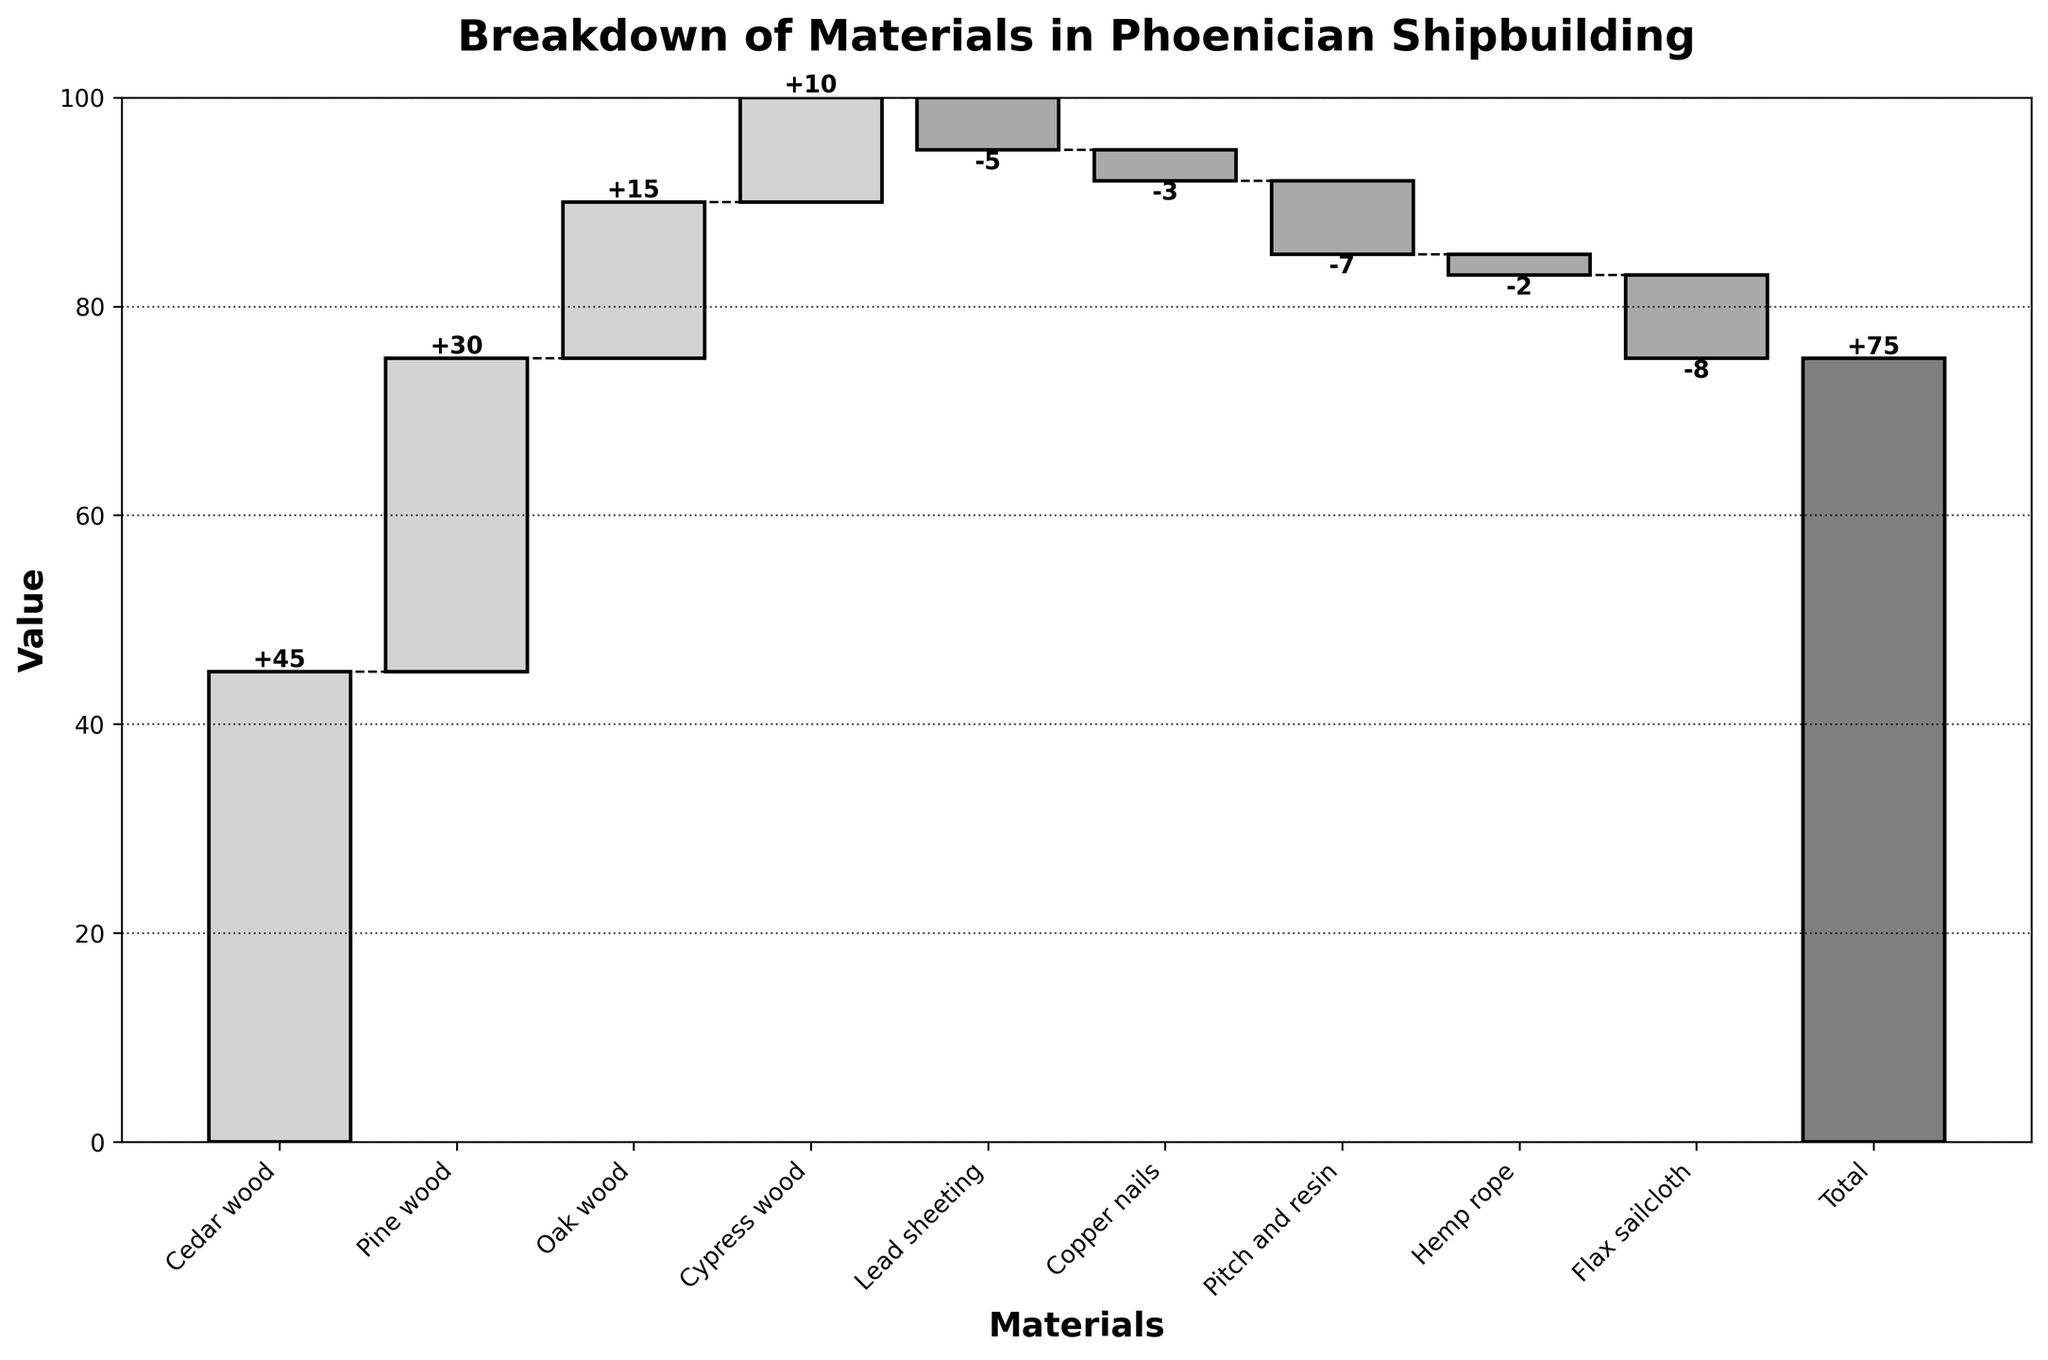What's the title of the chart? The title is usually at the top of the chart and indicates what the chart represents. In this case, the title should be easily readable.
Answer: Breakdown of Materials in Phoenician Shipbuilding How many materials are positively contributing to the total value? Materials that positively contribute will have positive values. By counting these from the bars that go upwards, we identify the count.
Answer: 4 Which material has the highest contribution? From the chart, we see which bar is the highest in terms of positive value. The highest bar indicates the largest contribution.
Answer: Cedar wood Which material has the smallest negative contribution? We look for the smallest negative value from the bars that go downward and identify the respective material.
Answer: Hemp rope How does the contribution of lead sheeting compare to copper nails? We observe the heights of the bars for lead sheeting and copper nails, both of which go downward, and compare their magnitudes.
Answer: Lead sheeting has a larger negative contribution than copper nails What's the net positive value before considering the negative values? We sum up the values of the positively contributing materials: Cedar wood (45), Pine wood (30), Oak wood (15), and Cypress wood (10).
Answer: 45 + 30 + 15 + 10 = 100 What is the net effect of materials that negatively contribute? We sum up the absolute values of the negatively contributing materials: Lead sheeting (5), Copper nails (3), Pitch and resin (7), Hemp rope (2), and Flax sailcloth (8).
Answer: 5 + 3 + 7 + 2 + 8 = 25 What final value does the chart indicate after considering both positive and negative contributions? The final 'Total' bar represents the net effect after all contributions: Positive (100) minus Negative (25).
Answer: 75 Which material causes the most reduction in the total value? The material with the highest bar going downward indicates the largest negative impact.
Answer: Flax sailcloth What would the total be if we excluded the impact of flax sailcloth? The original total is 75. Excluding the flax sailcloth (-8) would mean adding back 8 to the total.
Answer: 75 + 8 = 83 